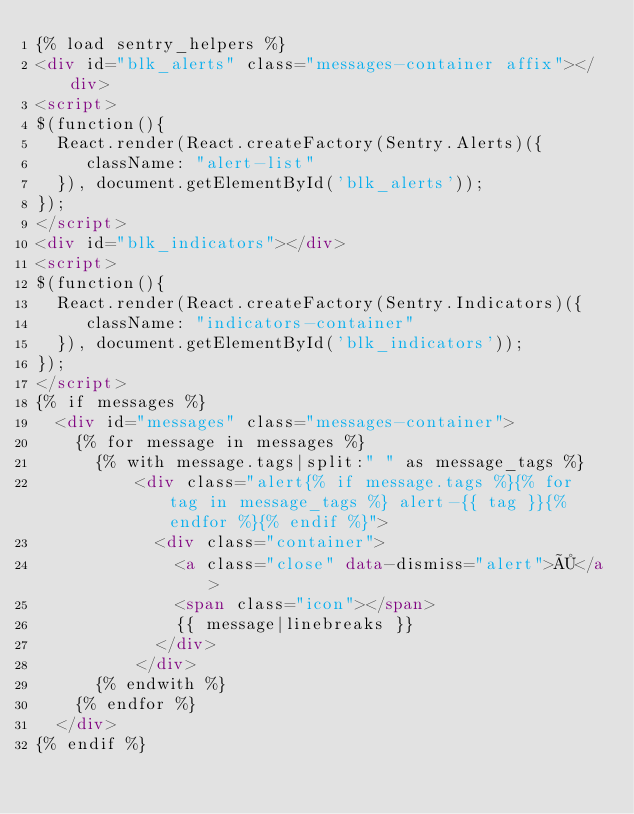<code> <loc_0><loc_0><loc_500><loc_500><_HTML_>{% load sentry_helpers %}
<div id="blk_alerts" class="messages-container affix"></div>
<script>
$(function(){
  React.render(React.createFactory(Sentry.Alerts)({
     className: "alert-list"
  }), document.getElementById('blk_alerts'));
});
</script>
<div id="blk_indicators"></div>
<script>
$(function(){
  React.render(React.createFactory(Sentry.Indicators)({
     className: "indicators-container"
  }), document.getElementById('blk_indicators'));
});
</script>
{% if messages %}
  <div id="messages" class="messages-container">
    {% for message in messages %}
    	{% with message.tags|split:" " as message_tags %}
          <div class="alert{% if message.tags %}{% for tag in message_tags %} alert-{{ tag }}{% endfor %}{% endif %}">
            <div class="container">
              <a class="close" data-dismiss="alert">×</a>
              <span class="icon"></span>
              {{ message|linebreaks }}
            </div>
          </div>
      {% endwith %}
    {% endfor %}
  </div>
{% endif %}
</code> 